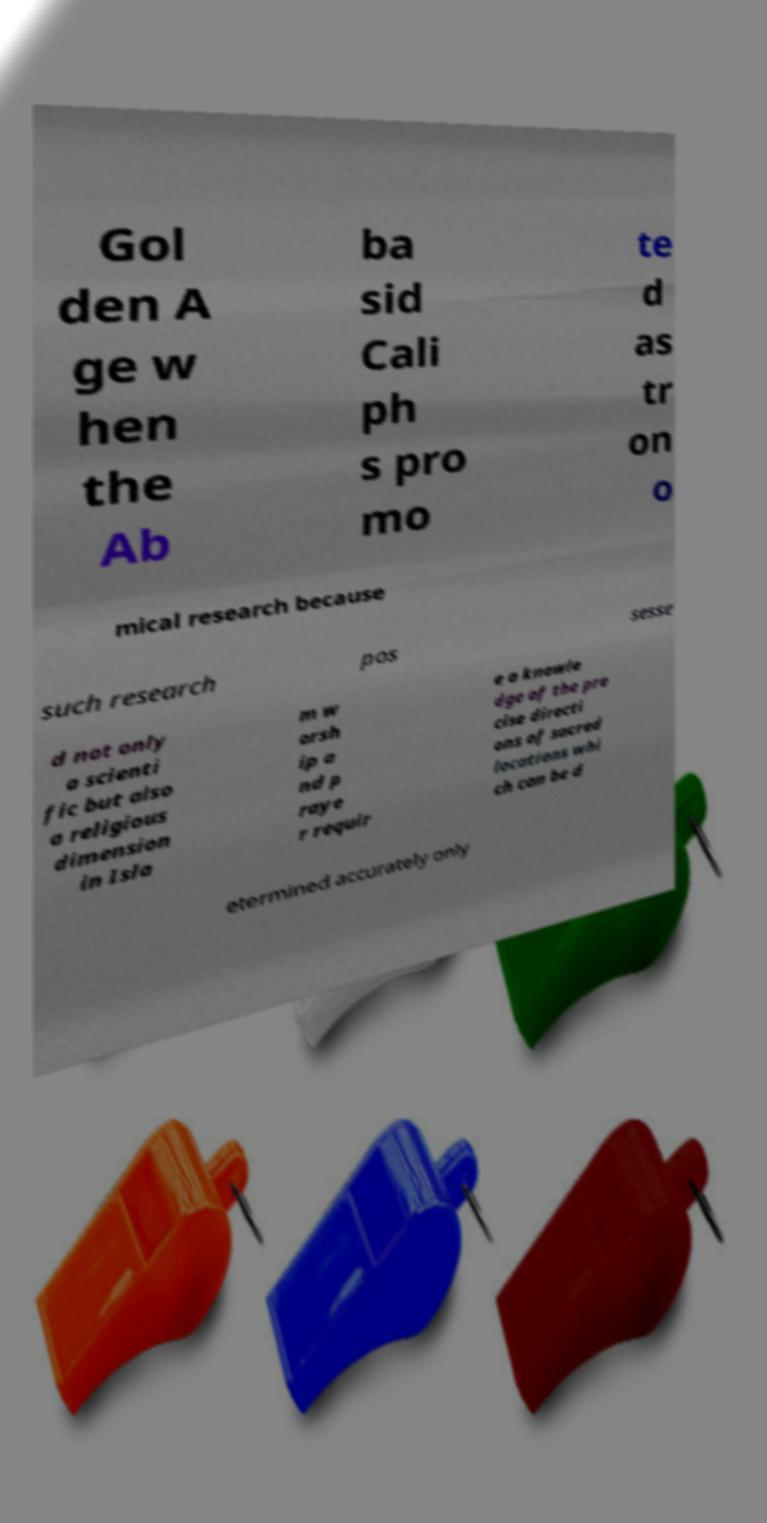Could you extract and type out the text from this image? Gol den A ge w hen the Ab ba sid Cali ph s pro mo te d as tr on o mical research because such research pos sesse d not only a scienti fic but also a religious dimension in Isla m w orsh ip a nd p raye r requir e a knowle dge of the pre cise directi ons of sacred locations whi ch can be d etermined accurately only 